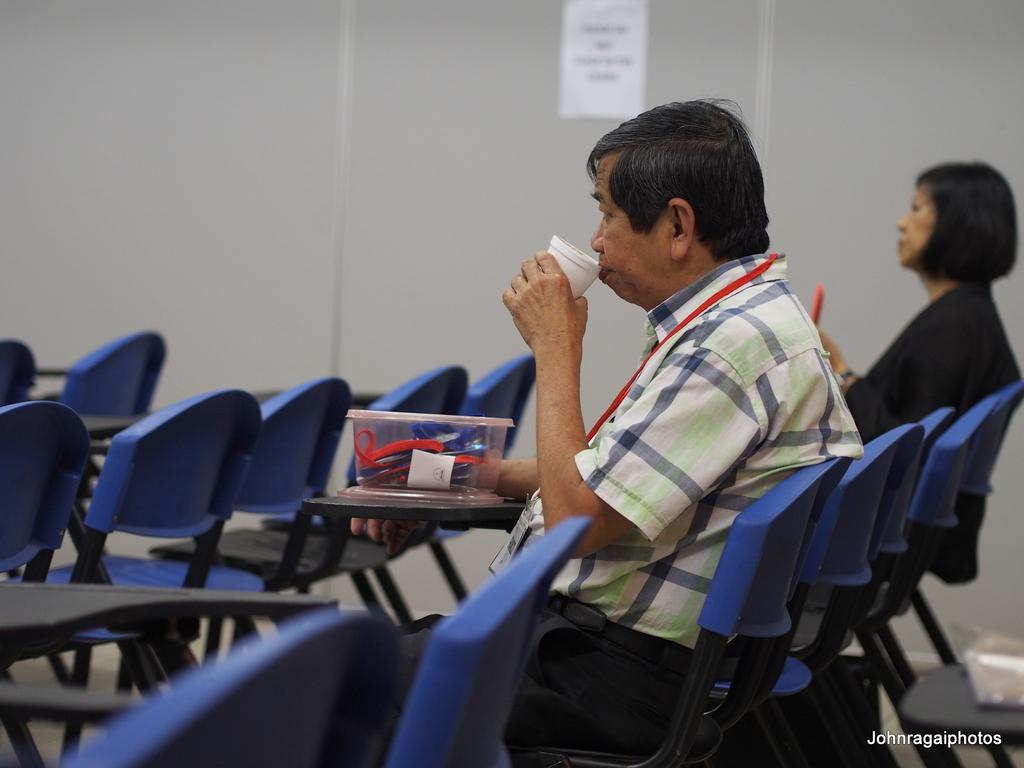How many people are in the image? There are two people in the image, a man and a woman. What are the man and woman doing in the image? Both the man and woman are sitting on chairs. What is the man holding in the image? The man is drinking from a cup. What object is in front of the man and woman? There is a box in front of them. What else can be seen in front of the man and woman? There are additional chairs in front of them. What is on the wall beside the man and woman? There is a wall with a sticker beside them. What type of skin can be seen on the tiger in the image? There is no tiger present in the image, so there is no skin to observe. What type of paper is the man reading in the image? There is no paper visible in the image, and the man is not shown reading anything. 